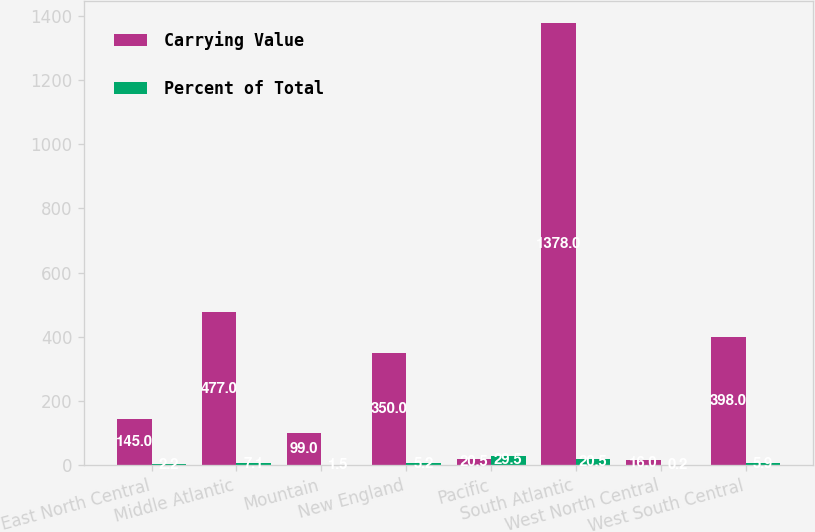Convert chart to OTSL. <chart><loc_0><loc_0><loc_500><loc_500><stacked_bar_chart><ecel><fcel>East North Central<fcel>Middle Atlantic<fcel>Mountain<fcel>New England<fcel>Pacific<fcel>South Atlantic<fcel>West North Central<fcel>West South Central<nl><fcel>Carrying Value<fcel>145<fcel>477<fcel>99<fcel>350<fcel>20.5<fcel>1378<fcel>16<fcel>398<nl><fcel>Percent of Total<fcel>2.2<fcel>7.1<fcel>1.5<fcel>5.2<fcel>29.5<fcel>20.5<fcel>0.2<fcel>5.9<nl></chart> 